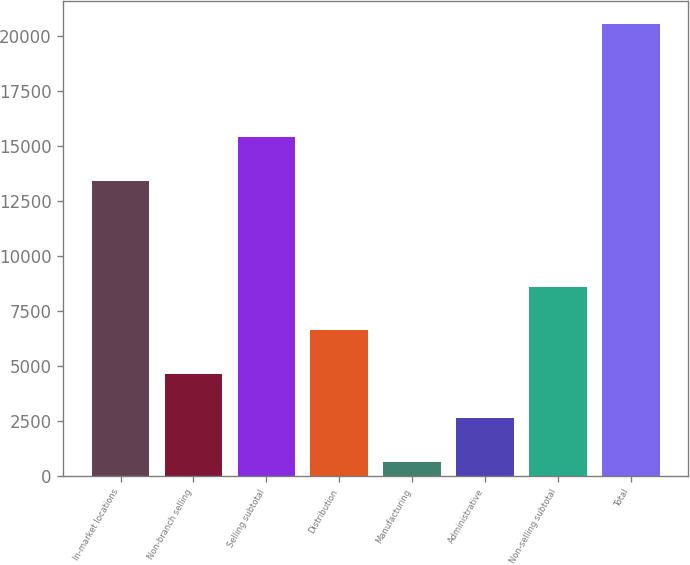Convert chart. <chart><loc_0><loc_0><loc_500><loc_500><bar_chart><fcel>In-market locations<fcel>Non-branch selling<fcel>Selling subtotal<fcel>Distribution<fcel>Manufacturing<fcel>Administrative<fcel>Non-selling subtotal<fcel>Total<nl><fcel>13424<fcel>4634.6<fcel>15415.3<fcel>6625.9<fcel>652<fcel>2643.3<fcel>8617.2<fcel>20565<nl></chart> 